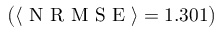Convert formula to latex. <formula><loc_0><loc_0><loc_500><loc_500>\left ( \langle N R M S E \rangle = 1 . 3 0 1 \right )</formula> 